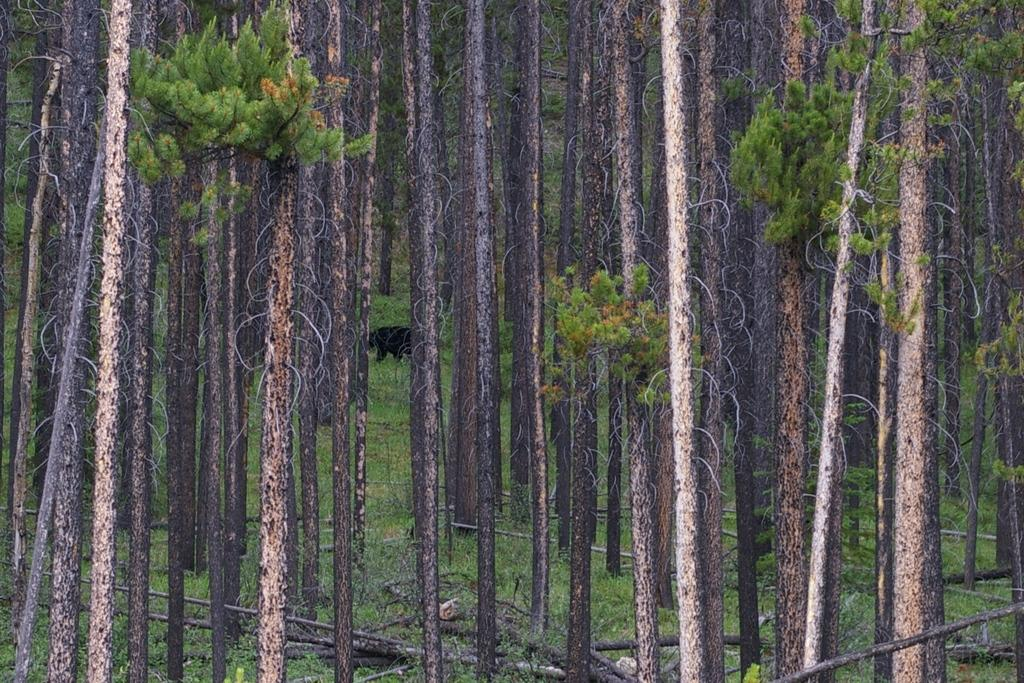What type of vegetation can be seen in the image? There are trees in the image. What other living creature is present in the image? There is an animal in the image. What material is visible at the bottom of the image? Wooden logs are present at the bottom of the image. What type of ground surface is visible in the image? Grass is visible on the surface in the image. What type of quilt is being used to cover the animal in the image? There is no quilt present in the image; the animal is not covered. What type of vessel is being used to transport the wooden logs in the image? There is no vessel present in the image; the wooden logs are stationary at the bottom. 